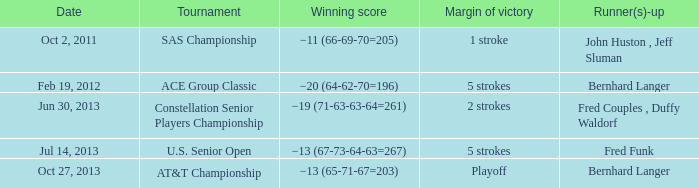Which Tournament has a Date of jul 14, 2013? U.S. Senior Open. 